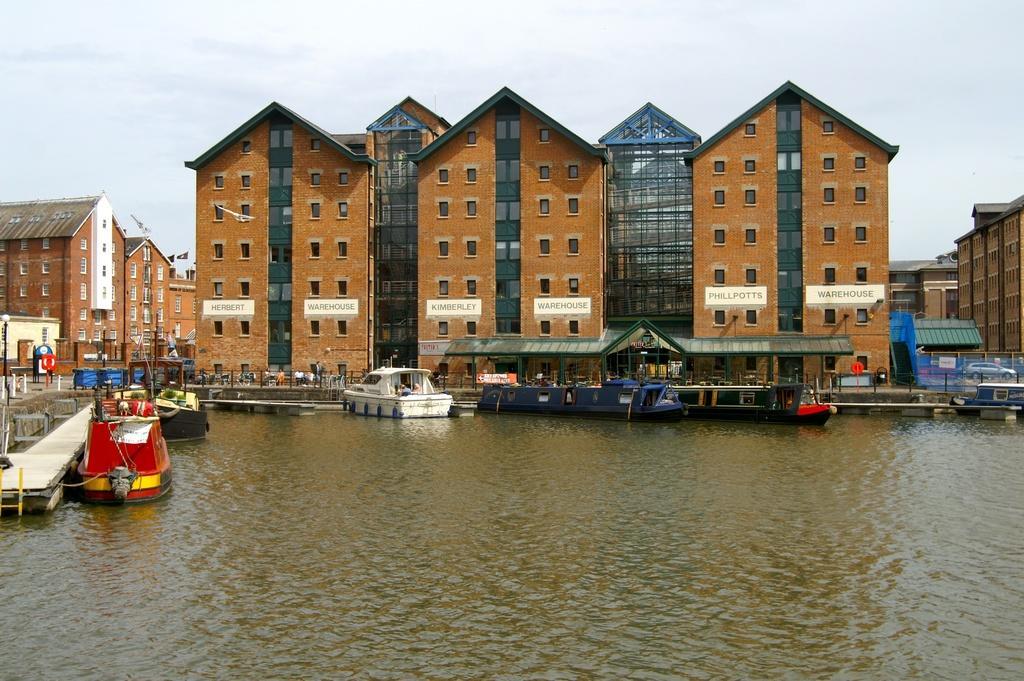How would you summarize this image in a sentence or two? In this image at the bottom there is a river, and on the left side there is a bridge and in the river there are some boats. In the background there are some buildings and some persons are walking, and also there are some poles and boards and on the board there is some text. And at the top of there is image the sky and on the right side there is one car. 